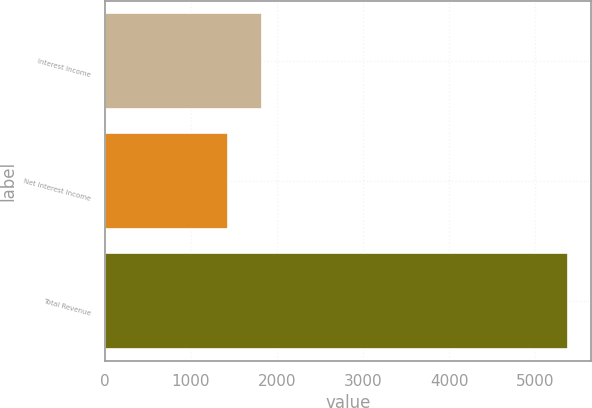Convert chart. <chart><loc_0><loc_0><loc_500><loc_500><bar_chart><fcel>Interest Income<fcel>Net Interest Income<fcel>Total Revenue<nl><fcel>1823.81<fcel>1429.2<fcel>5375.3<nl></chart> 